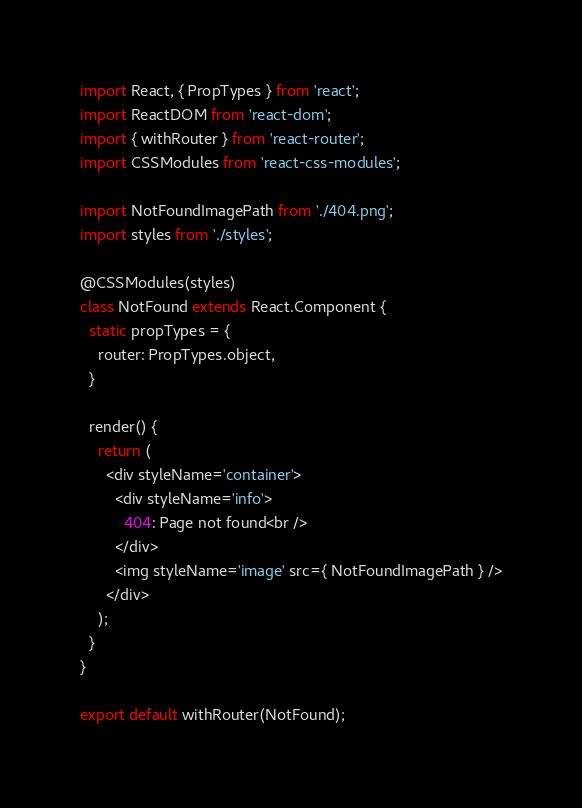<code> <loc_0><loc_0><loc_500><loc_500><_JavaScript_>import React, { PropTypes } from 'react';
import ReactDOM from 'react-dom';
import { withRouter } from 'react-router';
import CSSModules from 'react-css-modules';

import NotFoundImagePath from './404.png';
import styles from './styles';

@CSSModules(styles)
class NotFound extends React.Component {
  static propTypes = {
    router: PropTypes.object,
  }

  render() {
    return (
      <div styleName='container'>
        <div styleName='info'>
          404: Page not found<br />
        </div>
        <img styleName='image' src={ NotFoundImagePath } />
      </div>
    );
  }
}

export default withRouter(NotFound);
</code> 